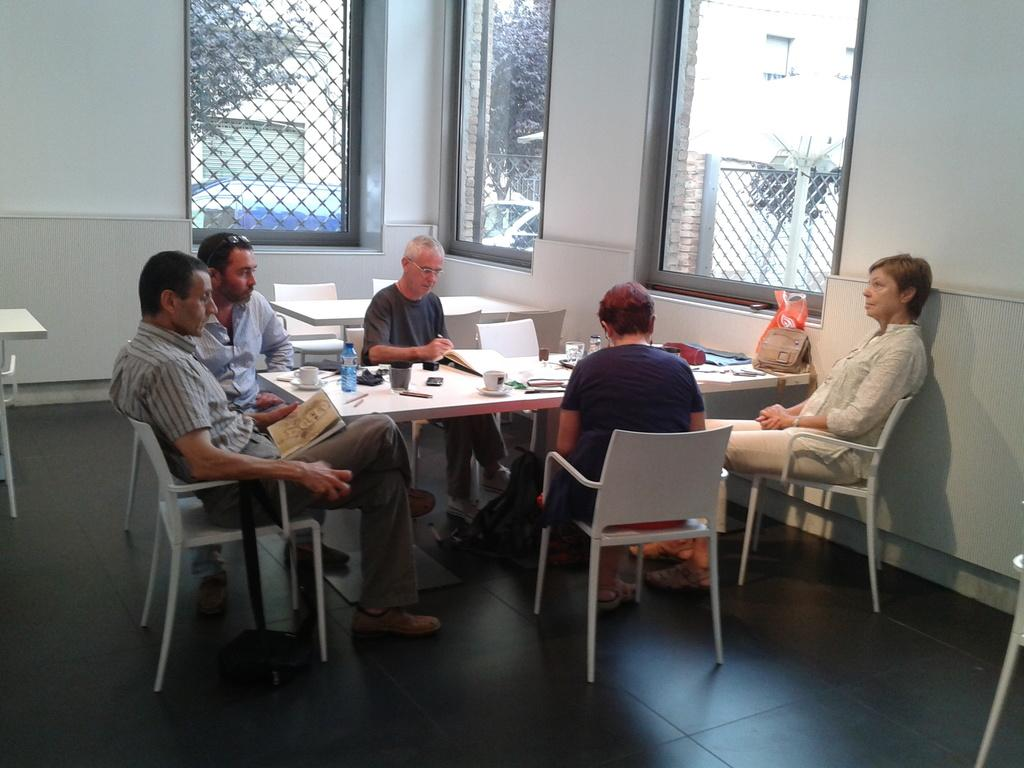What is happening in the image? There are people sitting around a table. What items can be seen on the table? Papers, books, and other objects are present on the table. Can you describe the surroundings of the room? There are windows in the wall. What type of rod is being used by the person in the image? There is no person using a rod in the image; the image only shows people sitting around a table. What kind of system is being used to organize the books on the table? There is no system visible for organizing the books on the table; they are simply placed on the table. 